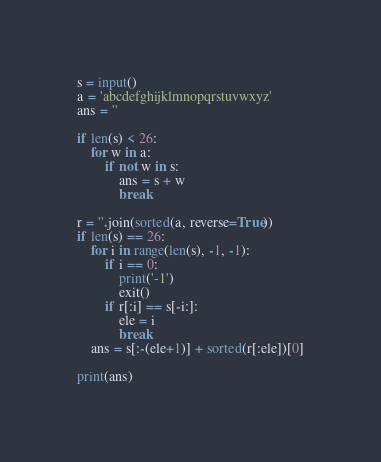<code> <loc_0><loc_0><loc_500><loc_500><_Python_>s = input()
a = 'abcdefghijklmnopqrstuvwxyz'
ans = ''

if len(s) < 26:
    for w in a:
        if not w in s:
            ans = s + w
            break

r = ''.join(sorted(a, reverse=True))
if len(s) == 26:
    for i in range(len(s), -1, -1):
        if i == 0:
            print('-1')
            exit()
        if r[:i] == s[-i:]:
            ele = i
            break
    ans = s[:-(ele+1)] + sorted(r[:ele])[0]

print(ans)</code> 